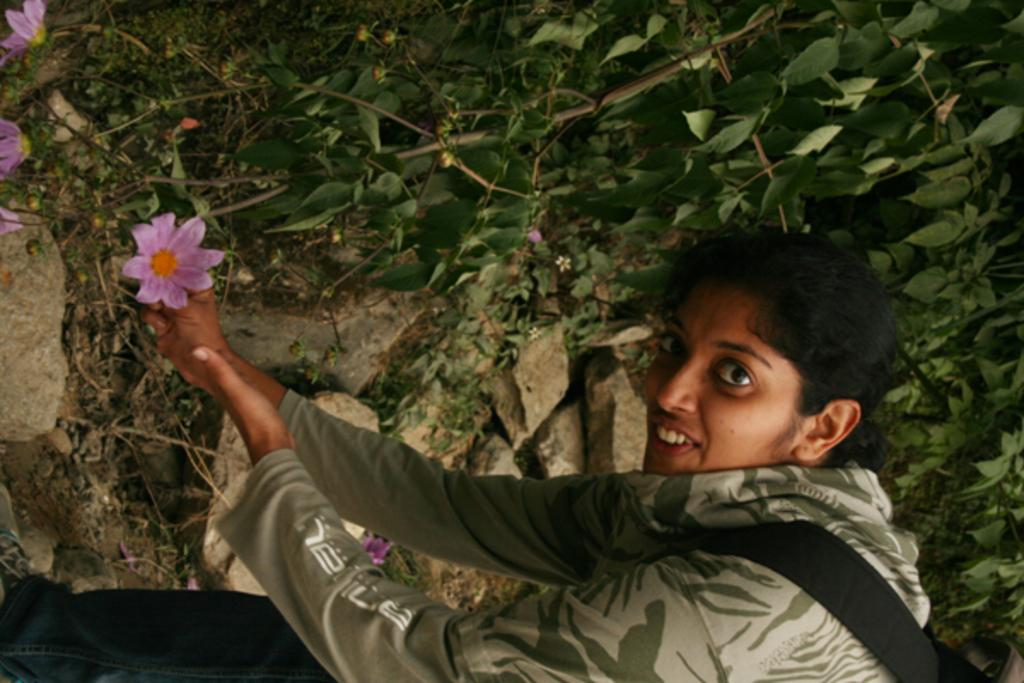Who is present in the image? There is a lady in the image. What can be seen in the background of the image? There are plants in the background of the image. What type of vegetation is visible in the image? There are flowers visible in the image. What other objects can be seen in the image? There are stones in the image. What type of clouds can be seen in the image? There are no clouds visible in the image. Is there a battle taking place in the image? There is no battle depicted in the image. 